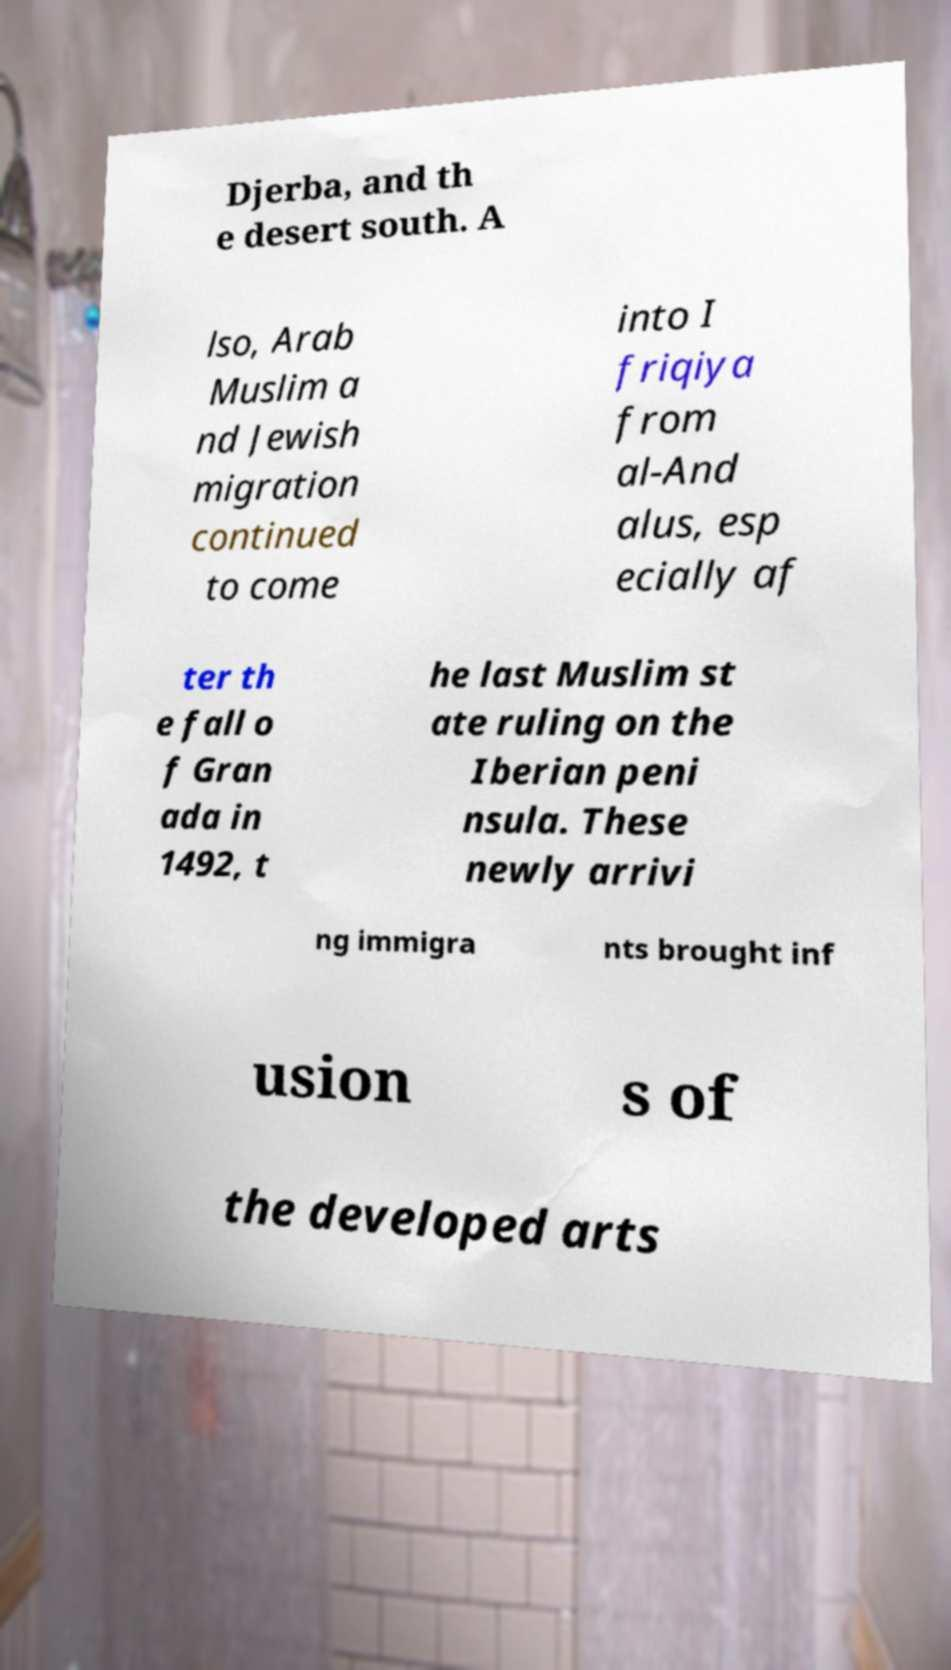There's text embedded in this image that I need extracted. Can you transcribe it verbatim? Djerba, and th e desert south. A lso, Arab Muslim a nd Jewish migration continued to come into I friqiya from al-And alus, esp ecially af ter th e fall o f Gran ada in 1492, t he last Muslim st ate ruling on the Iberian peni nsula. These newly arrivi ng immigra nts brought inf usion s of the developed arts 